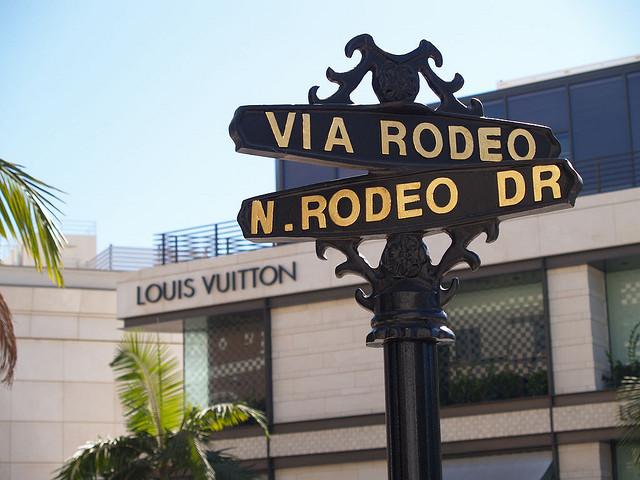What does the sign say?
Keep it brief. Via rodeo. Are the street signs new?
Concise answer only. Yes. Where is big mamma?
Concise answer only. N rodeo dr. Would it be more painful to sit on this sign than it would a bull?
Give a very brief answer. Yes. What is the name of the street?
Write a very short answer. N rodeo dr. What country is this?
Short answer required. Usa. Would you likely be able to purchase clothing at this location?
Concise answer only. Yes. Is this picture taken in the US?
Be succinct. Yes. What store is in the back?
Be succinct. Louis vuitton. What color is the signs?
Answer briefly. Black. What street sign is at the bottom?
Write a very short answer. N rodeo dr. What directions does Main Street run?
Give a very brief answer. North. Is this an expensive store?
Give a very brief answer. Yes. 